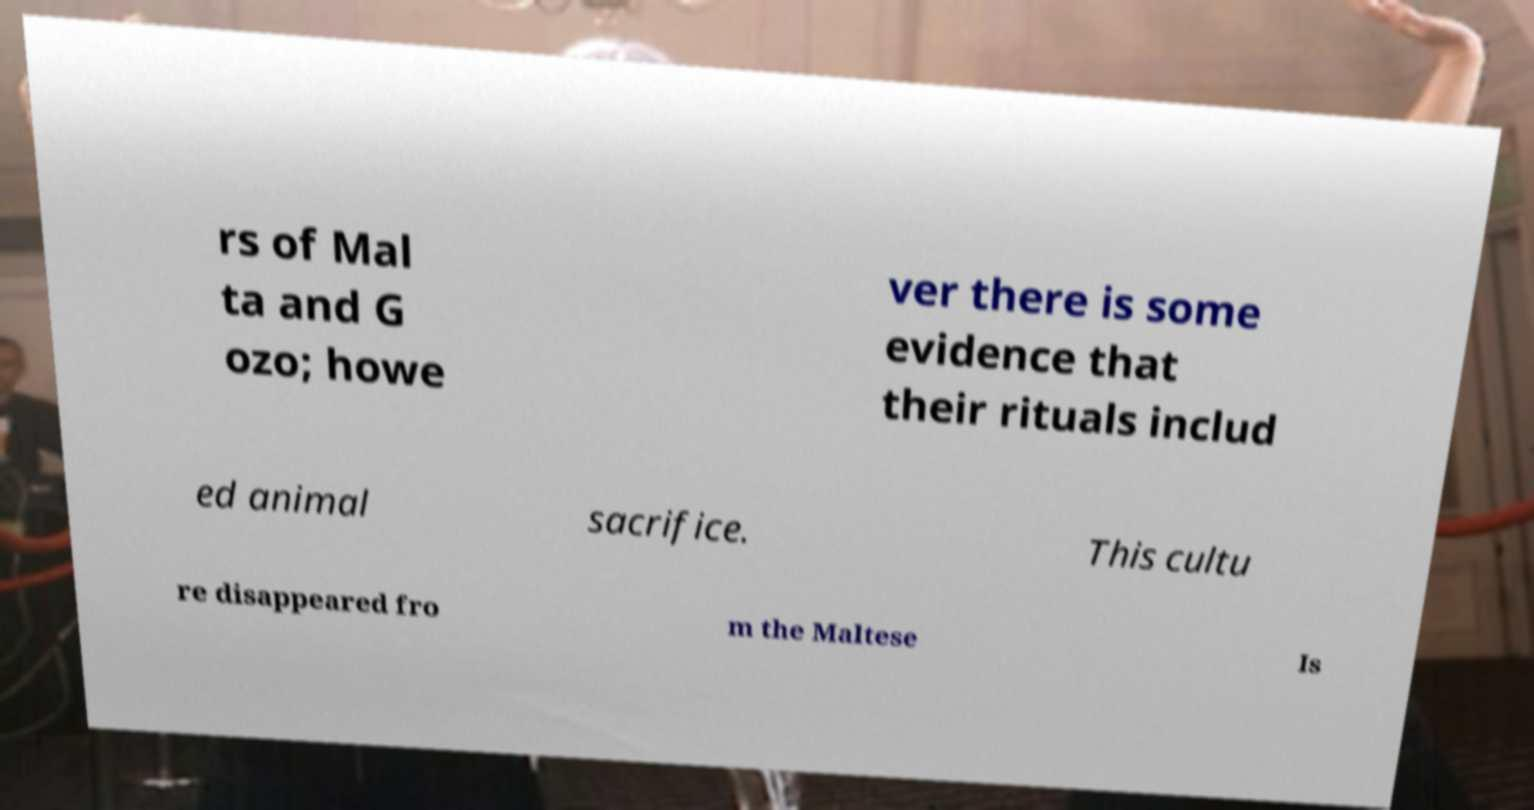For documentation purposes, I need the text within this image transcribed. Could you provide that? rs of Mal ta and G ozo; howe ver there is some evidence that their rituals includ ed animal sacrifice. This cultu re disappeared fro m the Maltese Is 